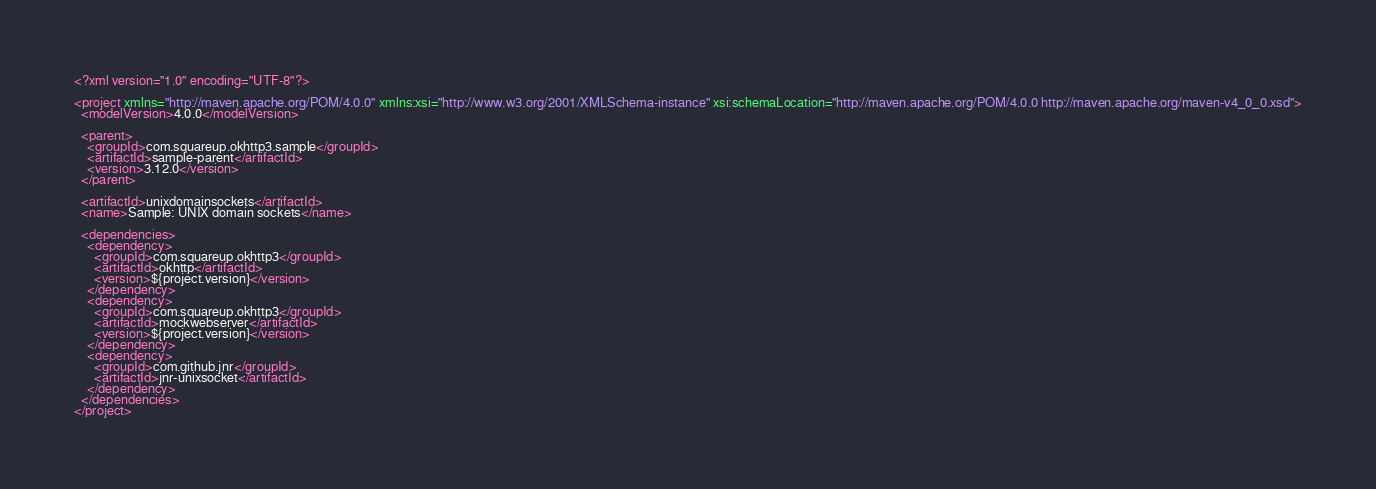<code> <loc_0><loc_0><loc_500><loc_500><_XML_><?xml version="1.0" encoding="UTF-8"?>

<project xmlns="http://maven.apache.org/POM/4.0.0" xmlns:xsi="http://www.w3.org/2001/XMLSchema-instance" xsi:schemaLocation="http://maven.apache.org/POM/4.0.0 http://maven.apache.org/maven-v4_0_0.xsd">
  <modelVersion>4.0.0</modelVersion>

  <parent>
    <groupId>com.squareup.okhttp3.sample</groupId>
    <artifactId>sample-parent</artifactId>
    <version>3.12.0</version>
  </parent>

  <artifactId>unixdomainsockets</artifactId>
  <name>Sample: UNIX domain sockets</name>

  <dependencies>
    <dependency>
      <groupId>com.squareup.okhttp3</groupId>
      <artifactId>okhttp</artifactId>
      <version>${project.version}</version>
    </dependency>
    <dependency>
      <groupId>com.squareup.okhttp3</groupId>
      <artifactId>mockwebserver</artifactId>
      <version>${project.version}</version>
    </dependency>
    <dependency>
      <groupId>com.github.jnr</groupId>
      <artifactId>jnr-unixsocket</artifactId>
    </dependency>
  </dependencies>
</project>
</code> 